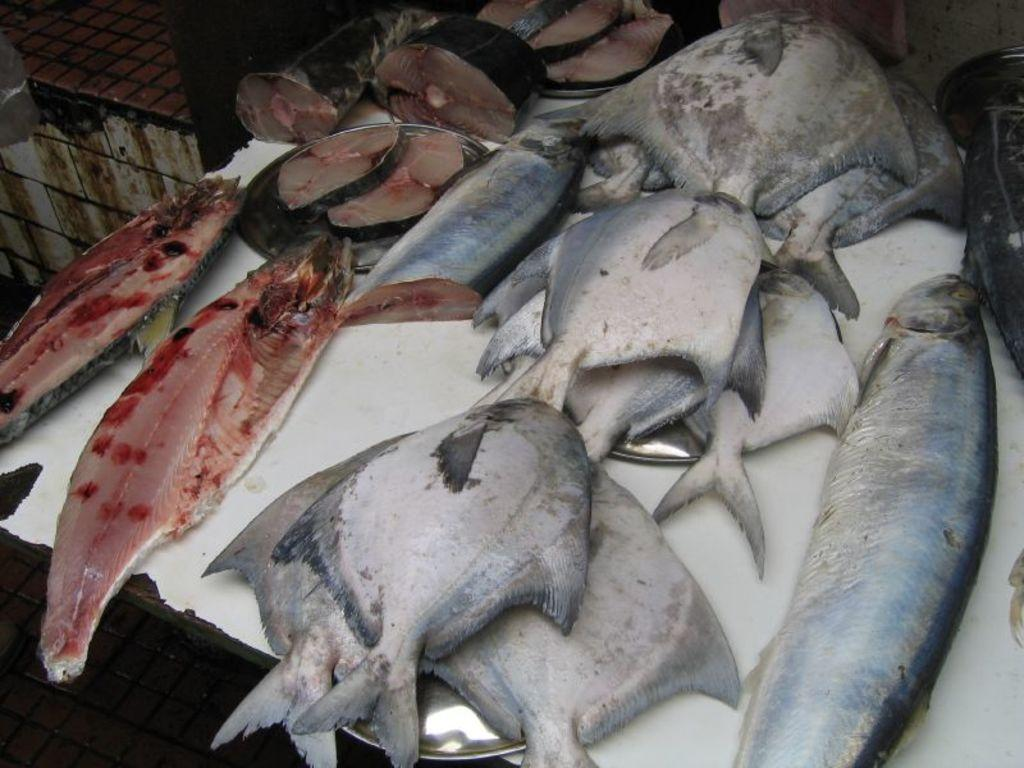What is placed on the table in the image? There are fishes on a table in the image. What color is the table with the fishes? The table is white. Where is the table with the fishes located in the image? The table with the fishes is in the middle of the image. What else can be seen on another table in the image? There is another table in the top left corner of the image, but no specific details are provided about what is on it. What type of station is visible in the image? There is no station present in the image; it features a table with fishes and another table in the top left corner. What color is the cover on the table with the fishes? There is no cover on the table with the fishes in the image. 